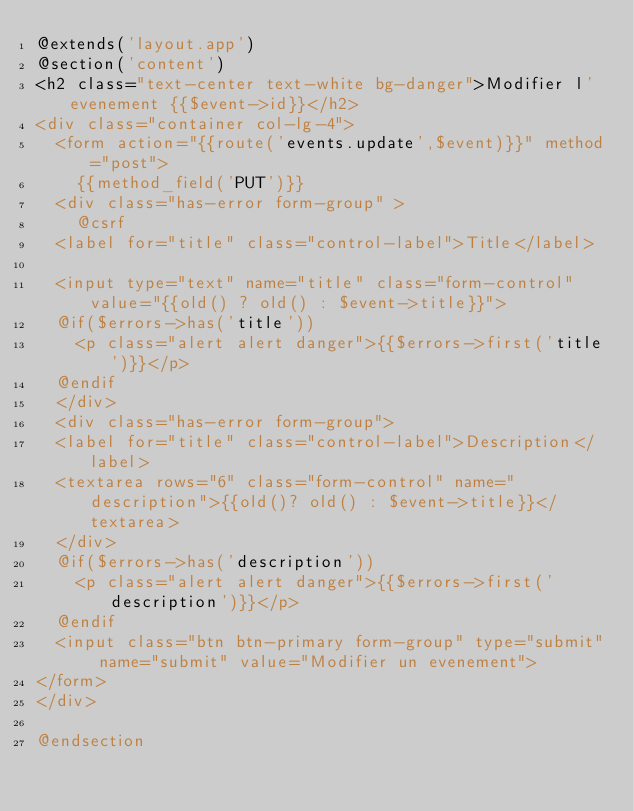<code> <loc_0><loc_0><loc_500><loc_500><_PHP_>@extends('layout.app')
@section('content')
<h2 class="text-center text-white bg-danger">Modifier l'evenement {{$event->id}}</h2>
<div class="container col-lg-4">
	<form action="{{route('events.update',$event)}}" method="post">
		{{method_field('PUT')}}
	<div class="has-error form-group" >
		@csrf
	<label for="title" class="control-label">Title</label>
	
	<input type="text" name="title" class="form-control" value="{{old() ? old() : $event->title}}">
	@if($errors->has('title'))
		<p class="alert alert danger">{{$errors->first('title')}}</p>
	@endif	
	</div>
	<div class="has-error form-group">
	<label for="title" class="control-label">Description</label>
	<textarea rows="6" class="form-control" name="description">{{old()? old() : $event->title}}</textarea>	
	</div>
	@if($errors->has('description'))
		<p class="alert alert danger">{{$errors->first('description')}}</p>
	@endif
	<input class="btn btn-primary form-group" type="submit" name="submit" value="Modifier un evenement">
</form>
</div>

@endsection</code> 